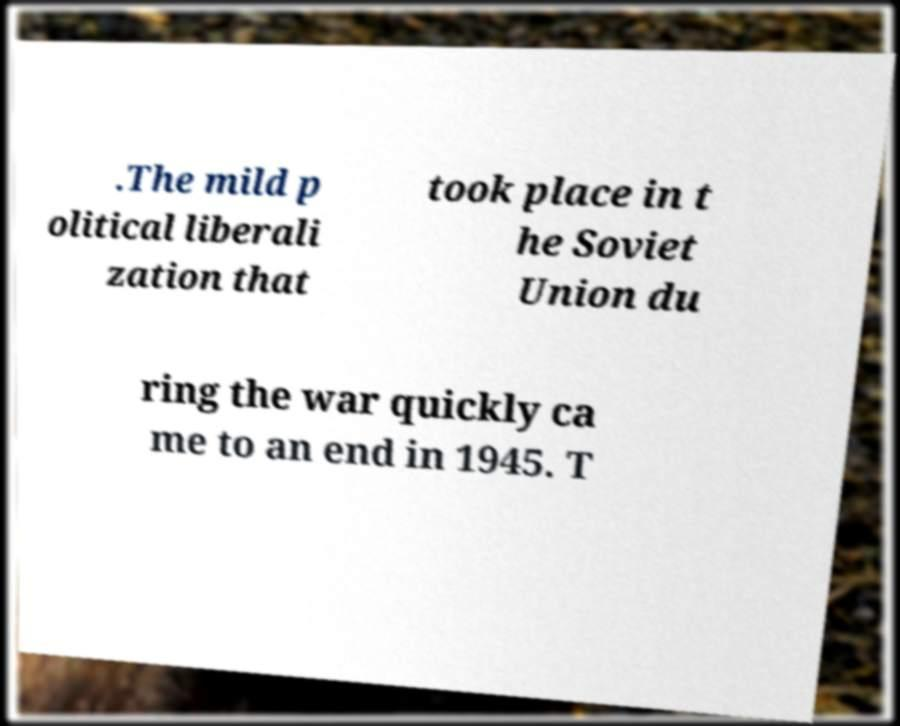I need the written content from this picture converted into text. Can you do that? .The mild p olitical liberali zation that took place in t he Soviet Union du ring the war quickly ca me to an end in 1945. T 